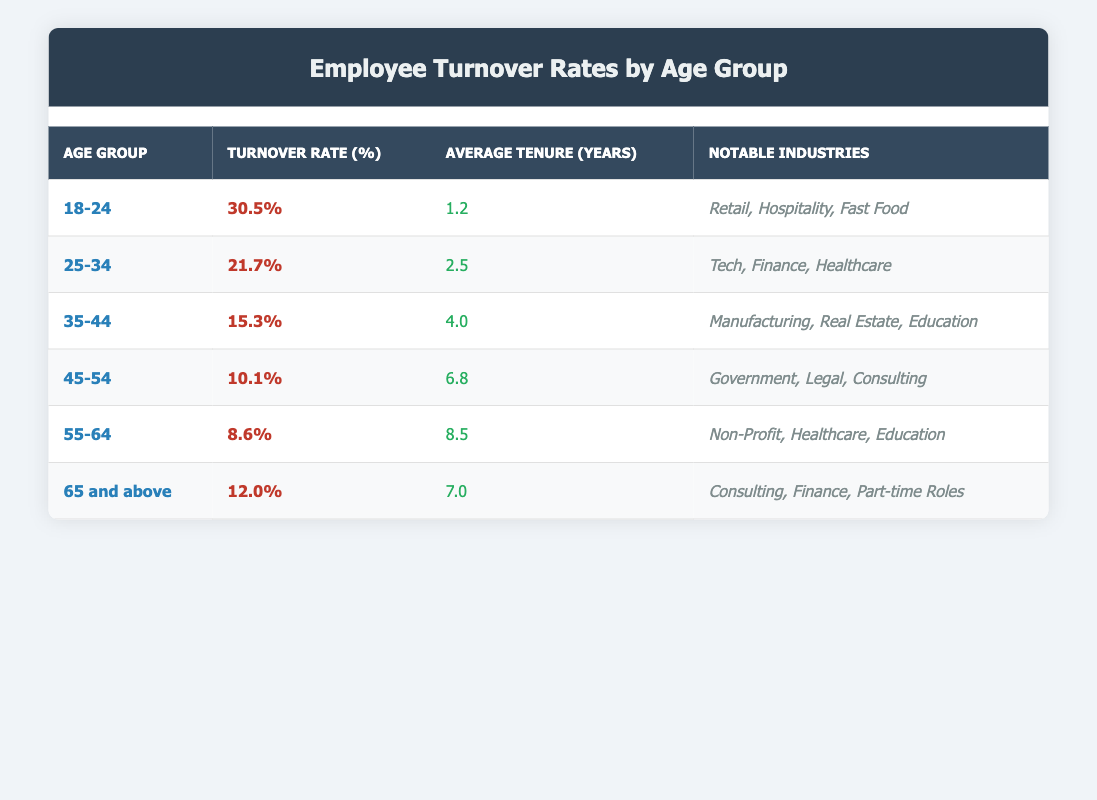What is the turnover rate for the age group 25-34? The turnover rate for the age group 25-34 is explicitly stated in the table. It shows 21.7% for this age group.
Answer: 21.7% Which age group has the highest turnover rate? Looking through the table, the age group 18-24 has the highest turnover rate at 30.5%, surpassing all other age groups listed.
Answer: 18-24 How much higher is the turnover rate for ages 18-24 compared to ages 55-64? The turnover rate for 18-24 is 30.5%, while for 55-64 it is 8.6%. Subtracting these rates gives: 30.5 - 8.6 = 21.9%. Thus, 21.9% is the difference.
Answer: 21.9% What is the average tenure in years for employees aged 45-54? Referring to the table, the average tenure for the age group 45-54 is listed as 6.8 years.
Answer: 6.8 years Is the average tenure for the age group 35-44 greater than that of the age group 65 and above? The average tenure for the age group 35-44 is 4.0 years, and for 65 and above, it is 7.0 years. Since 4.0 is less than 7.0, the answer is no.
Answer: No How many age groups have a turnover rate of less than 15%? By analyzing the table, the age groups with a turnover rate less than 15% are 45-54 (10.1%) and 55-64 (8.6%). Thus, there are 3 age groups: 45-54, 55-64, and 65 and above (12.0%). The total count is 3 age groups with turnover rates below 15%.
Answer: 3 What is the combined turnover rate for the age groups 45-54 and 55-64? The turnover rate for 45-54 is 10.1% and for 55-64 is 8.6%. Adding these two rates results in a combined turnover rate of 10.1 + 8.6 = 18.7%.
Answer: 18.7% Which age group has the lowest turnover rate? Analyzing the table, it’s clear that the age group 55-64 has the lowest turnover rate at 8.6%.
Answer: 55-64 Are the notable industries for the age group 25-34 more varied than those for the age group 18-24? The age group 25-34 has notable industries of Tech, Finance, and Healthcare while the age group 18-24 has Retail, Hospitality, and Fast Food. Both have three industries listed, so they are equally varied. The answer is therefore yes, they have an equal variety.
Answer: Yes 